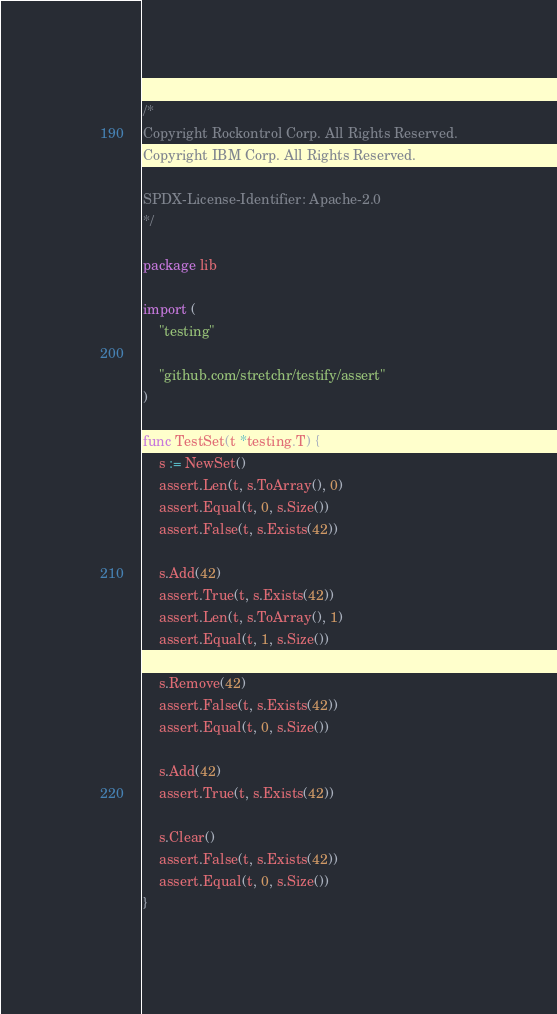Convert code to text. <code><loc_0><loc_0><loc_500><loc_500><_Go_>/*
Copyright Rockontrol Corp. All Rights Reserved.
Copyright IBM Corp. All Rights Reserved.

SPDX-License-Identifier: Apache-2.0
*/

package lib

import (
	"testing"

	"github.com/stretchr/testify/assert"
)

func TestSet(t *testing.T) {
	s := NewSet()
	assert.Len(t, s.ToArray(), 0)
	assert.Equal(t, 0, s.Size())
	assert.False(t, s.Exists(42))

	s.Add(42)
	assert.True(t, s.Exists(42))
	assert.Len(t, s.ToArray(), 1)
	assert.Equal(t, 1, s.Size())

	s.Remove(42)
	assert.False(t, s.Exists(42))
	assert.Equal(t, 0, s.Size())

	s.Add(42)
	assert.True(t, s.Exists(42))

	s.Clear()
	assert.False(t, s.Exists(42))
	assert.Equal(t, 0, s.Size())
}
</code> 